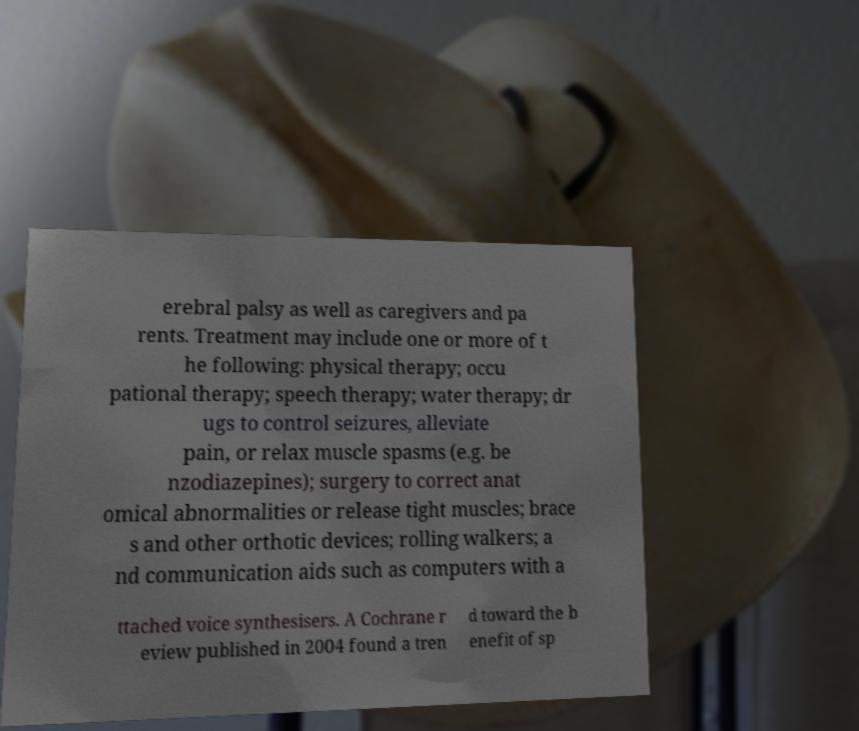Could you assist in decoding the text presented in this image and type it out clearly? erebral palsy as well as caregivers and pa rents. Treatment may include one or more of t he following: physical therapy; occu pational therapy; speech therapy; water therapy; dr ugs to control seizures, alleviate pain, or relax muscle spasms (e.g. be nzodiazepines); surgery to correct anat omical abnormalities or release tight muscles; brace s and other orthotic devices; rolling walkers; a nd communication aids such as computers with a ttached voice synthesisers. A Cochrane r eview published in 2004 found a tren d toward the b enefit of sp 